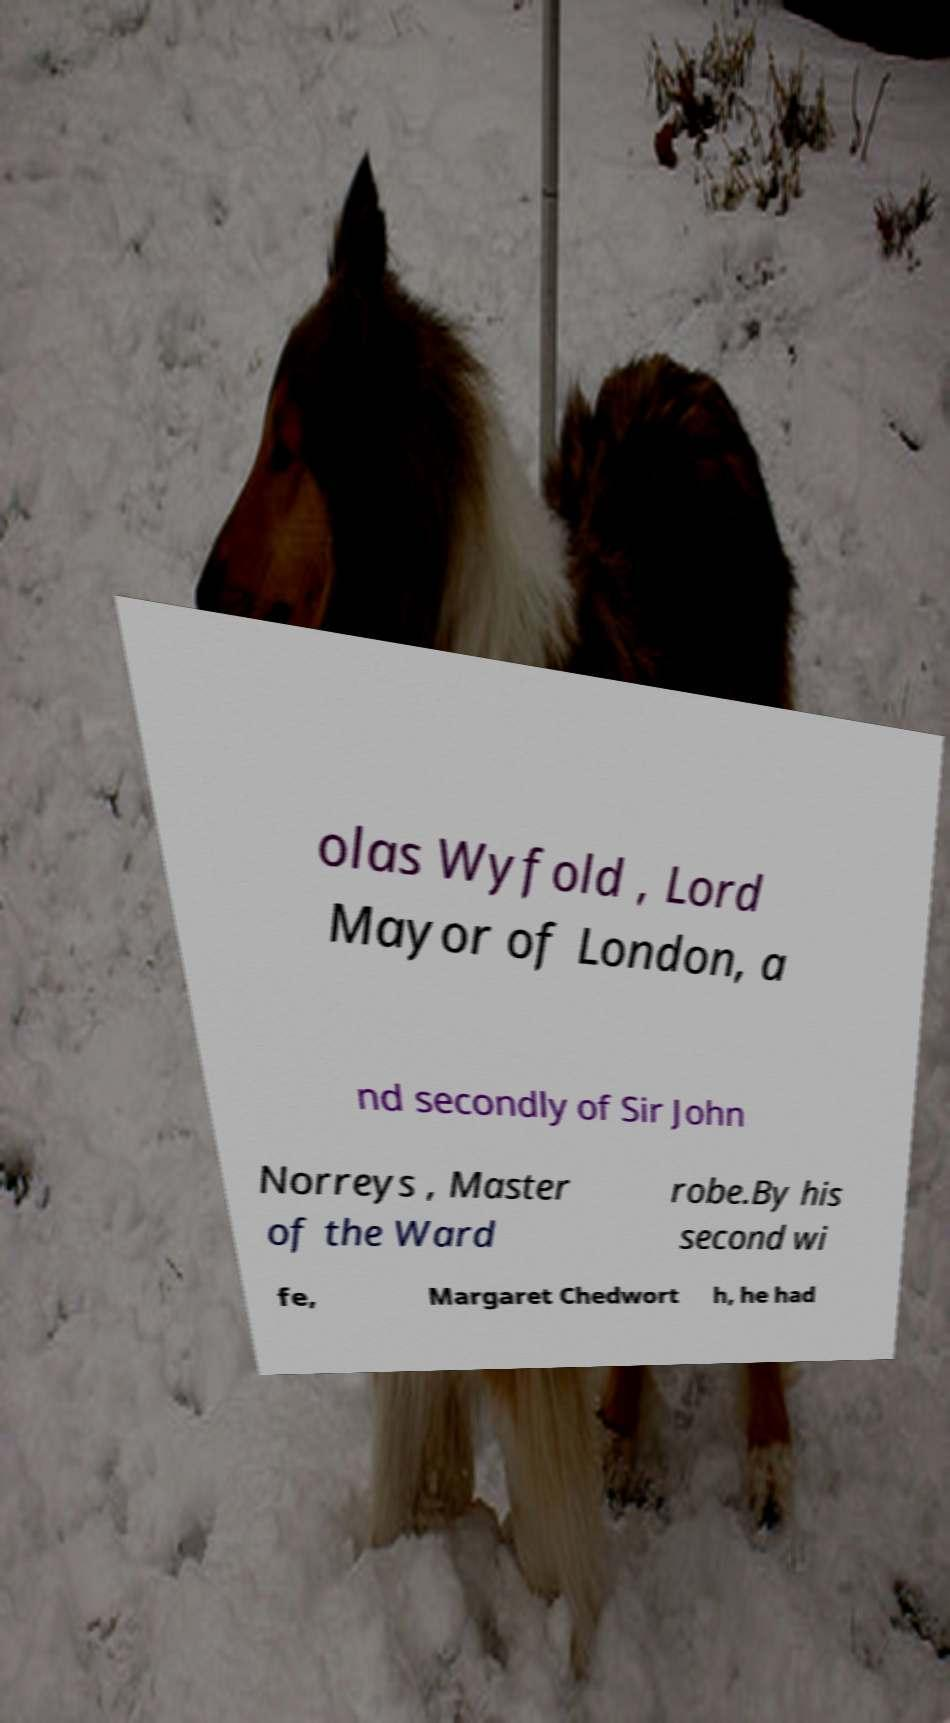Can you read and provide the text displayed in the image?This photo seems to have some interesting text. Can you extract and type it out for me? olas Wyfold , Lord Mayor of London, a nd secondly of Sir John Norreys , Master of the Ward robe.By his second wi fe, Margaret Chedwort h, he had 